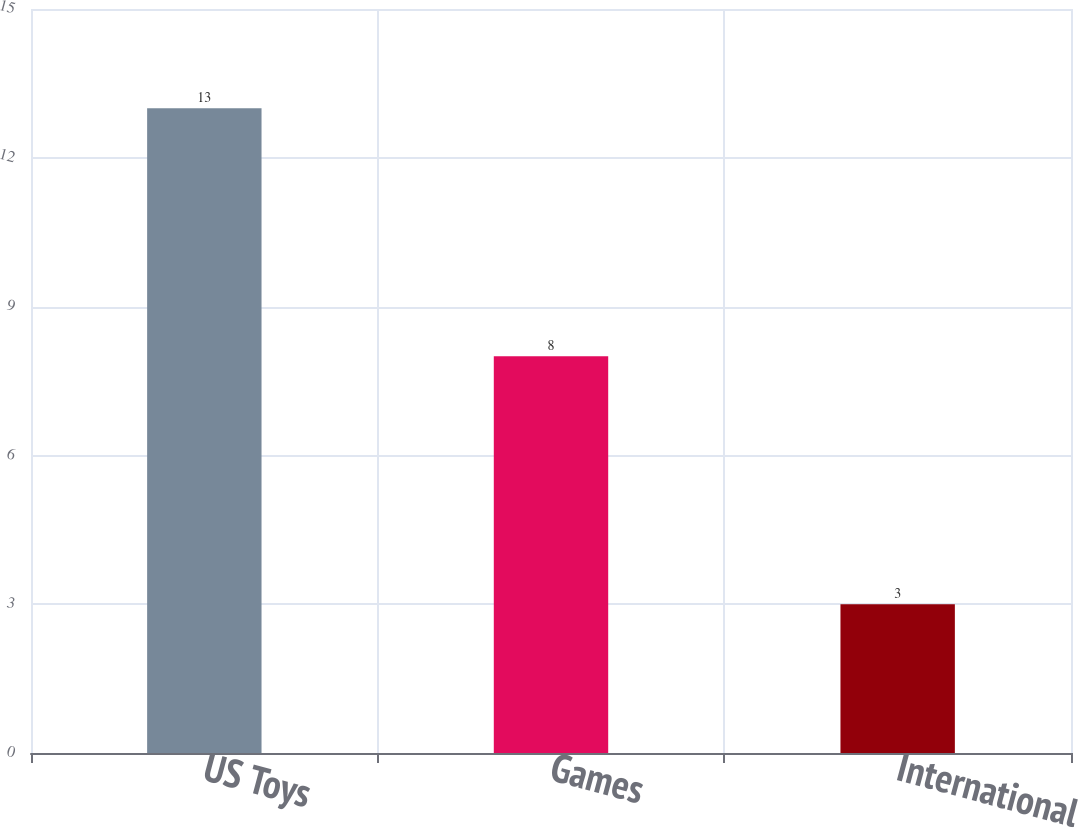<chart> <loc_0><loc_0><loc_500><loc_500><bar_chart><fcel>US Toys<fcel>Games<fcel>International<nl><fcel>13<fcel>8<fcel>3<nl></chart> 